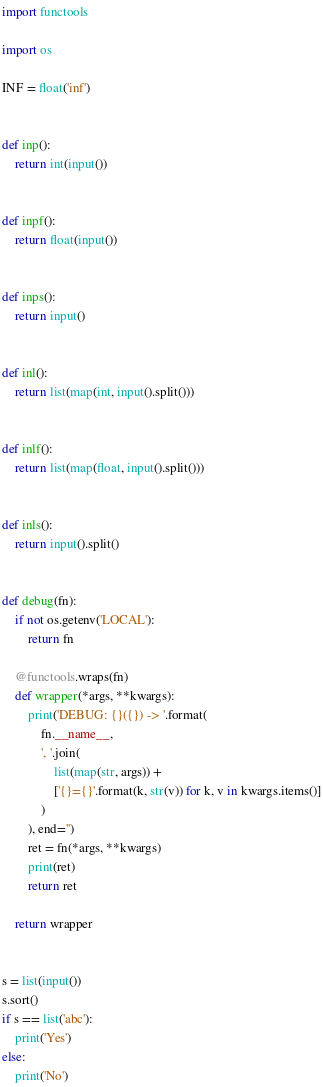Convert code to text. <code><loc_0><loc_0><loc_500><loc_500><_Python_>import functools

import os

INF = float('inf')


def inp():
    return int(input())


def inpf():
    return float(input())


def inps():
    return input()


def inl():
    return list(map(int, input().split()))


def inlf():
    return list(map(float, input().split()))


def inls():
    return input().split()


def debug(fn):
    if not os.getenv('LOCAL'):
        return fn

    @functools.wraps(fn)
    def wrapper(*args, **kwargs):
        print('DEBUG: {}({}) -> '.format(
            fn.__name__,
            ', '.join(
                list(map(str, args)) +
                ['{}={}'.format(k, str(v)) for k, v in kwargs.items()]
            )
        ), end='')
        ret = fn(*args, **kwargs)
        print(ret)
        return ret

    return wrapper


s = list(input())
s.sort()
if s == list('abc'):
    print('Yes')
else:
    print('No')
</code> 